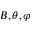Convert formula to latex. <formula><loc_0><loc_0><loc_500><loc_500>B , \theta , \varphi</formula> 